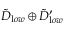Convert formula to latex. <formula><loc_0><loc_0><loc_500><loc_500>{ \tilde { D } } _ { l o w } \oplus { \tilde { D } } _ { l o w } ^ { \prime }</formula> 